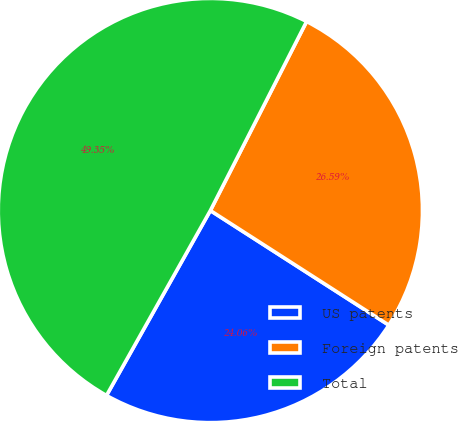Convert chart to OTSL. <chart><loc_0><loc_0><loc_500><loc_500><pie_chart><fcel>US patents<fcel>Foreign patents<fcel>Total<nl><fcel>24.06%<fcel>26.59%<fcel>49.35%<nl></chart> 